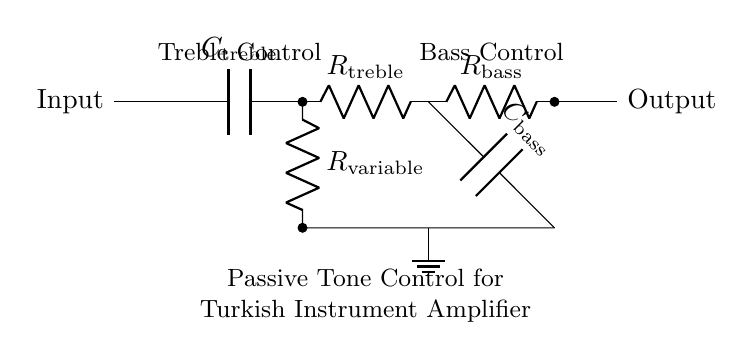What components are used in the treble control circuit? The treble control circuit consists of a capacitor and two resistors: a treble capacitor and a treble resistor. They are connected in series, which allows treble frequencies to pass while attenuating lower frequencies.
Answer: Capacitor, treble resistor What is the role of R variable in the circuit? R variable is a potentiometer used to adjust the amount of treble boost or cut in the amplifier. By varying its resistance, it changes how much treble frequencies are let through, effectively controlling the timbre of the output sound.
Answer: Treble adjustment How many capacitors are in the circuit? The diagram shows two capacitors: one for treble control and another for bass control. These capacitors play crucial roles in shaping the frequency response of the amplifier by filtering specific frequency ranges.
Answer: Two What is the function of the low-pass filter in this circuit? The low-pass filter, consisting of a bass capacitor and a bass resistor, allows low frequencies to pass while blocking higher frequency signals. This is important for maintaining a rich, full sound in low-frequency musical content typical in Turkish music.
Answer: Block high frequencies Which resistor is responsible for bass control? The resistor in the bass control portion of the circuit is labeled as R bass. It works in conjunction with the bass capacitor to form a low-pass filter, enabling the adjustment of low-frequency response in the amplifier.
Answer: R bass What effect does increasing R variable have on treble response? Increasing R variable resistance reduces the amount of high frequencies passing through, effectively lowering the treble response. This allows for a more mellow sound, which is sometimes desirable in playing traditional Turkish music where softer tones are intended.
Answer: Lowers treble response Where is the ground connection in the circuit? The ground connection is made at the lower terminal of the treble control resistor and the lower terminal of the bass capacitor, providing a common reference point for both the treble and bass control circuits and ensuring proper operation.
Answer: Ground at R variable and C bass 